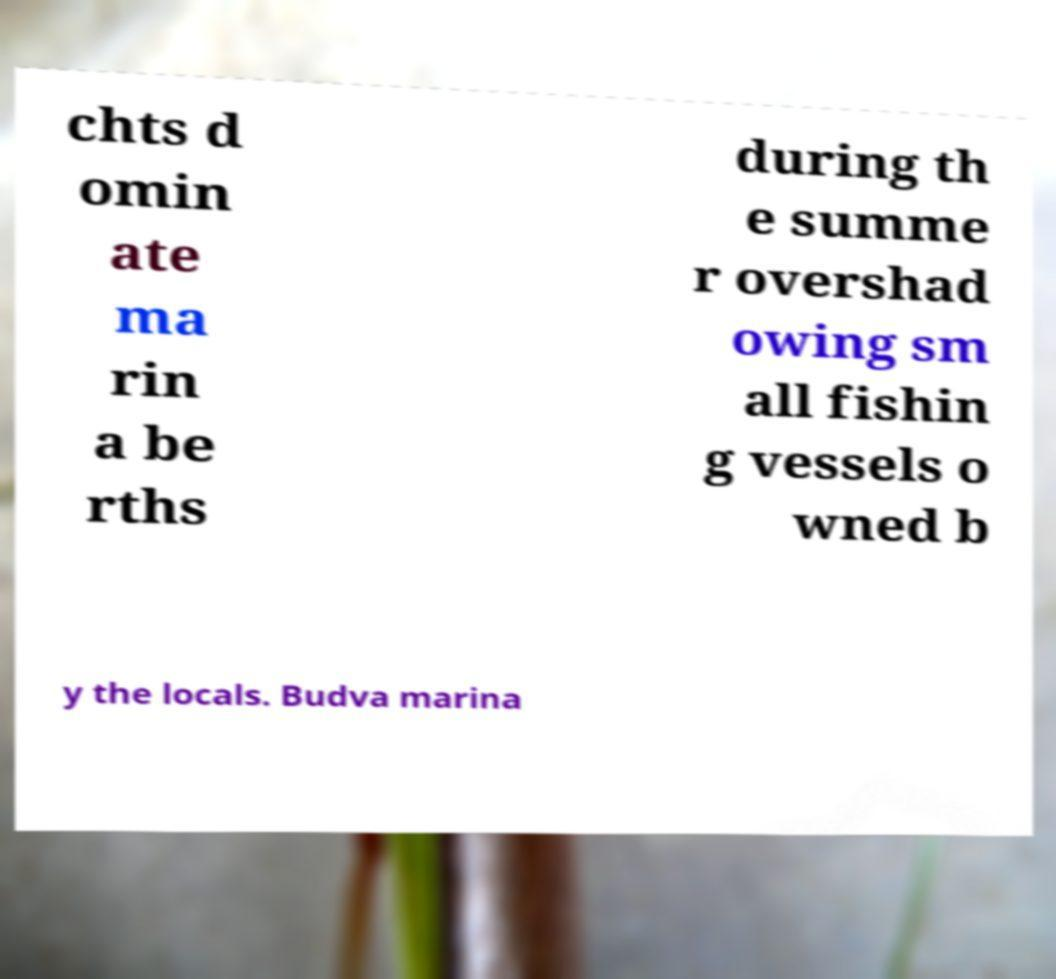Please read and relay the text visible in this image. What does it say? chts d omin ate ma rin a be rths during th e summe r overshad owing sm all fishin g vessels o wned b y the locals. Budva marina 